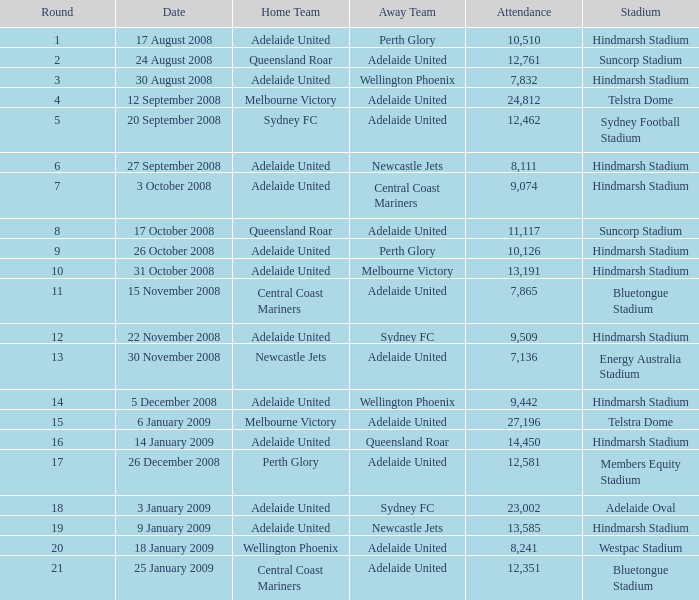What is the round when 11,117 people attended the game on 26 October 2008? 9.0. 